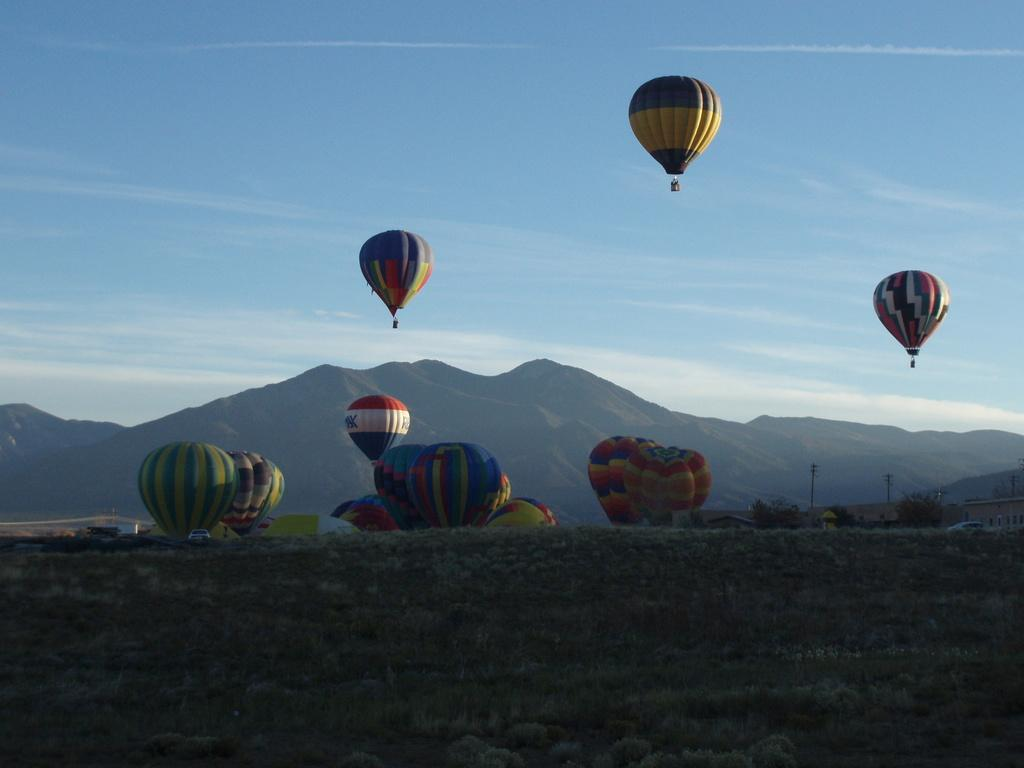What objects are related to transportation in the image? There are vehicles in the image. What structures are present in the image? There are buildings and poles in the image. What type of natural environment is visible in the image? There are trees and mountains in the image. What is visible in the sky in the image? The sky is visible in the image, and there are clouds present. What type of music can be heard coming from the boat in the image? There is no boat present in the image, so it is not possible to determine what, if any, music might be heard. 